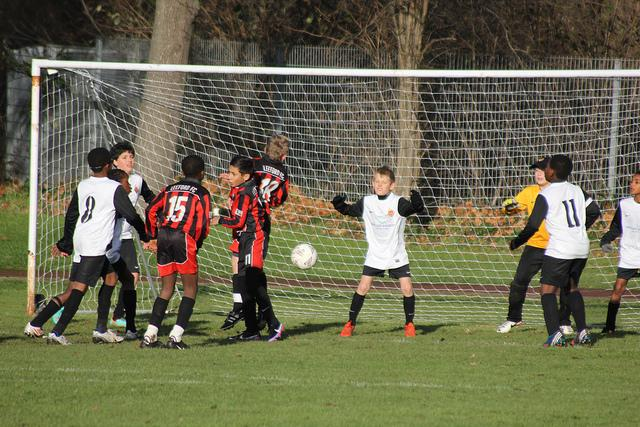Why is one kid wearing yellow?

Choices:
A) umpire
B) water boy
C) goalie
D) referee goalie 